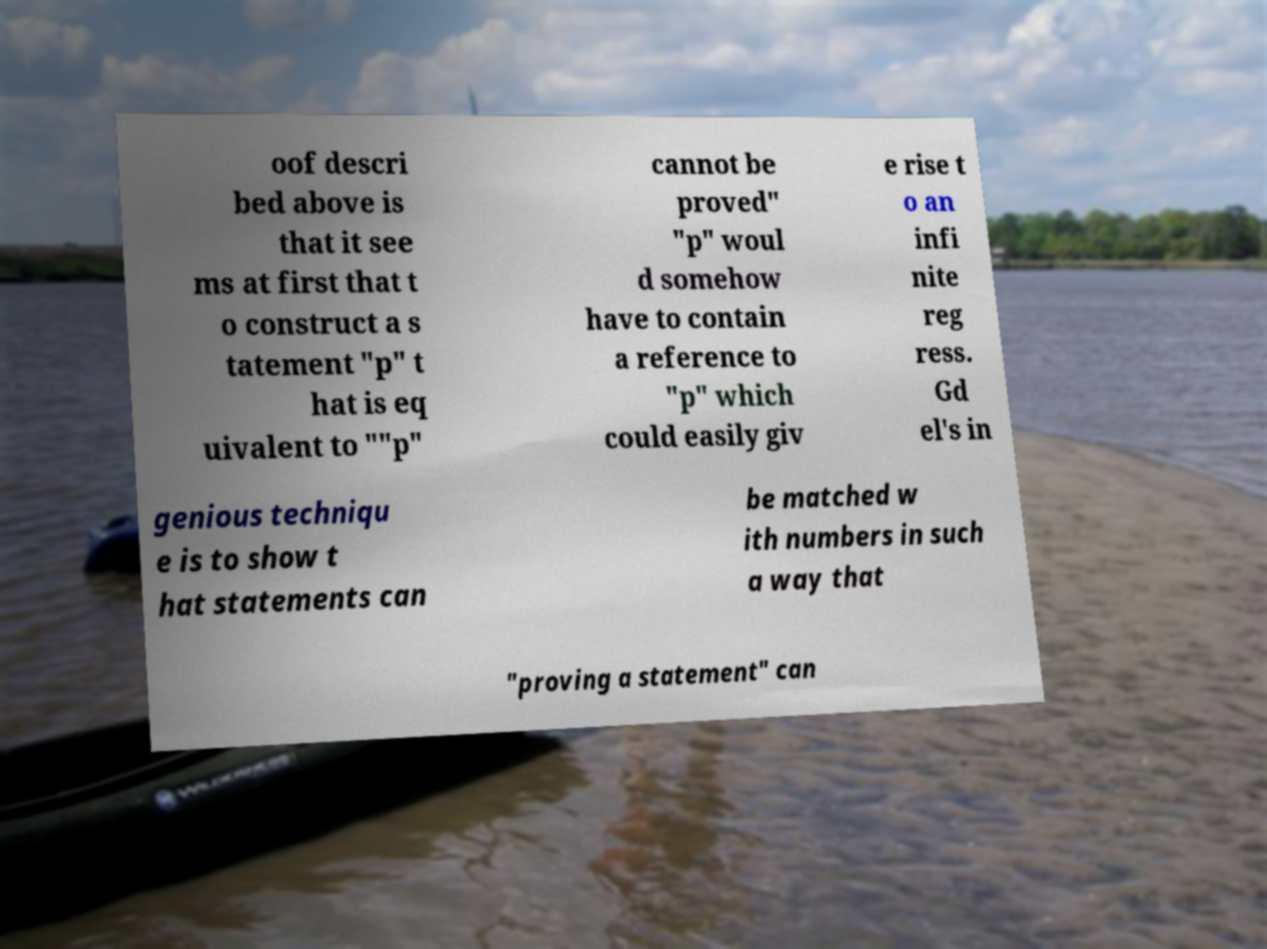Can you accurately transcribe the text from the provided image for me? oof descri bed above is that it see ms at first that t o construct a s tatement "p" t hat is eq uivalent to ""p" cannot be proved" "p" woul d somehow have to contain a reference to "p" which could easily giv e rise t o an infi nite reg ress. Gd el's in genious techniqu e is to show t hat statements can be matched w ith numbers in such a way that "proving a statement" can 